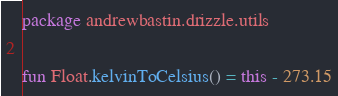<code> <loc_0><loc_0><loc_500><loc_500><_Kotlin_>package andrewbastin.drizzle.utils

fun Float.kelvinToCelsius() = this - 273.15</code> 